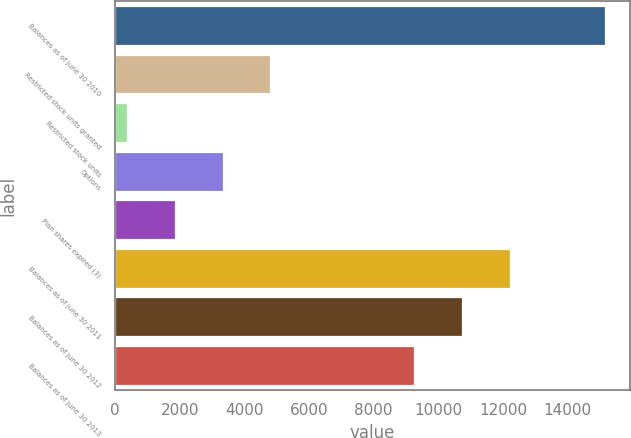<chart> <loc_0><loc_0><loc_500><loc_500><bar_chart><fcel>Balances as of June 30 2010<fcel>Restricted stock units granted<fcel>Restricted stock units<fcel>Options<fcel>Plan shares expired (3)<fcel>Balances as of June 30 2011<fcel>Balances as of June 30 2012<fcel>Balances as of June 30 2013<nl><fcel>15162<fcel>4805.5<fcel>367<fcel>3326<fcel>1846.5<fcel>12203<fcel>10723.5<fcel>9244<nl></chart> 